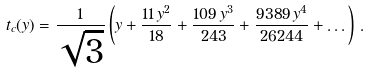Convert formula to latex. <formula><loc_0><loc_0><loc_500><loc_500>t _ { c } ( y ) = \frac { 1 } { \sqrt { 3 } } \left ( y + \frac { 1 1 \, { y } ^ { 2 } } { 1 8 } + \frac { 1 0 9 \, { y } ^ { 3 } } { 2 4 3 } + \frac { 9 3 8 9 \, { y } ^ { 4 } } { 2 6 2 4 4 } + \dots \right ) \, .</formula> 